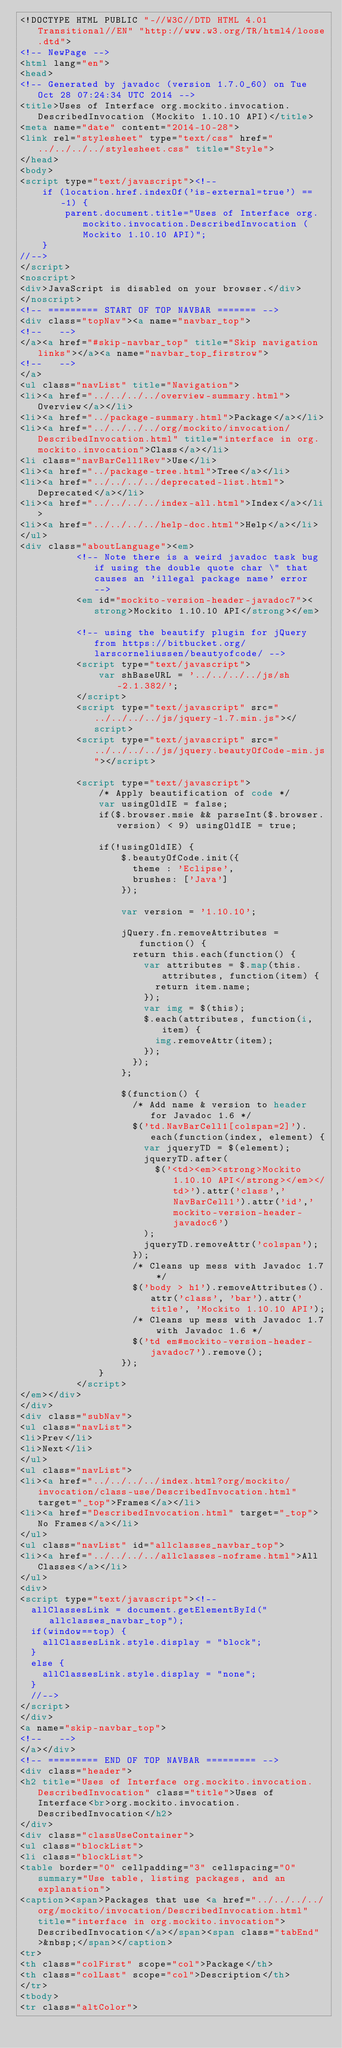<code> <loc_0><loc_0><loc_500><loc_500><_HTML_><!DOCTYPE HTML PUBLIC "-//W3C//DTD HTML 4.01 Transitional//EN" "http://www.w3.org/TR/html4/loose.dtd">
<!-- NewPage -->
<html lang="en">
<head>
<!-- Generated by javadoc (version 1.7.0_60) on Tue Oct 28 07:24:34 UTC 2014 -->
<title>Uses of Interface org.mockito.invocation.DescribedInvocation (Mockito 1.10.10 API)</title>
<meta name="date" content="2014-10-28">
<link rel="stylesheet" type="text/css" href="../../../../stylesheet.css" title="Style">
</head>
<body>
<script type="text/javascript"><!--
    if (location.href.indexOf('is-external=true') == -1) {
        parent.document.title="Uses of Interface org.mockito.invocation.DescribedInvocation (Mockito 1.10.10 API)";
    }
//-->
</script>
<noscript>
<div>JavaScript is disabled on your browser.</div>
</noscript>
<!-- ========= START OF TOP NAVBAR ======= -->
<div class="topNav"><a name="navbar_top">
<!--   -->
</a><a href="#skip-navbar_top" title="Skip navigation links"></a><a name="navbar_top_firstrow">
<!--   -->
</a>
<ul class="navList" title="Navigation">
<li><a href="../../../../overview-summary.html">Overview</a></li>
<li><a href="../package-summary.html">Package</a></li>
<li><a href="../../../../org/mockito/invocation/DescribedInvocation.html" title="interface in org.mockito.invocation">Class</a></li>
<li class="navBarCell1Rev">Use</li>
<li><a href="../package-tree.html">Tree</a></li>
<li><a href="../../../../deprecated-list.html">Deprecated</a></li>
<li><a href="../../../../index-all.html">Index</a></li>
<li><a href="../../../../help-doc.html">Help</a></li>
</ul>
<div class="aboutLanguage"><em>
          <!-- Note there is a weird javadoc task bug if using the double quote char \" that causes an 'illegal package name' error -->
          <em id="mockito-version-header-javadoc7"><strong>Mockito 1.10.10 API</strong></em>

          <!-- using the beautify plugin for jQuery from https://bitbucket.org/larscorneliussen/beautyofcode/ -->
          <script type="text/javascript">
              var shBaseURL = '../../../../js/sh-2.1.382/';
          </script>
          <script type="text/javascript" src="../../../../js/jquery-1.7.min.js"></script>
          <script type="text/javascript" src="../../../../js/jquery.beautyOfCode-min.js"></script>

          <script type="text/javascript">
              /* Apply beautification of code */
              var usingOldIE = false;
              if($.browser.msie && parseInt($.browser.version) < 9) usingOldIE = true;

              if(!usingOldIE) {
                  $.beautyOfCode.init({
                    theme : 'Eclipse',
                    brushes: ['Java']
                  });

                  var version = '1.10.10';

                  jQuery.fn.removeAttributes = function() {
                    return this.each(function() {
                      var attributes = $.map(this.attributes, function(item) {
                        return item.name;
                      });
                      var img = $(this);
                      $.each(attributes, function(i, item) {
                        img.removeAttr(item);
                      });
                    });
                  };

                  $(function() {
                    /* Add name & version to header for Javadoc 1.6 */
                    $('td.NavBarCell1[colspan=2]').each(function(index, element) {
                      var jqueryTD = $(element);
                      jqueryTD.after(
                        $('<td><em><strong>Mockito 1.10.10 API</strong></em></td>').attr('class','NavBarCell1').attr('id','mockito-version-header-javadoc6')
                      );
                      jqueryTD.removeAttr('colspan');
                    });
                    /* Cleans up mess with Javadoc 1.7 */
                    $('body > h1').removeAttributes().attr('class', 'bar').attr('title', 'Mockito 1.10.10 API');
                    /* Cleans up mess with Javadoc 1.7 with Javadoc 1.6 */
                    $('td em#mockito-version-header-javadoc7').remove();
                  });
              }
          </script>
</em></div>
</div>
<div class="subNav">
<ul class="navList">
<li>Prev</li>
<li>Next</li>
</ul>
<ul class="navList">
<li><a href="../../../../index.html?org/mockito/invocation/class-use/DescribedInvocation.html" target="_top">Frames</a></li>
<li><a href="DescribedInvocation.html" target="_top">No Frames</a></li>
</ul>
<ul class="navList" id="allclasses_navbar_top">
<li><a href="../../../../allclasses-noframe.html">All Classes</a></li>
</ul>
<div>
<script type="text/javascript"><!--
  allClassesLink = document.getElementById("allclasses_navbar_top");
  if(window==top) {
    allClassesLink.style.display = "block";
  }
  else {
    allClassesLink.style.display = "none";
  }
  //-->
</script>
</div>
<a name="skip-navbar_top">
<!--   -->
</a></div>
<!-- ========= END OF TOP NAVBAR ========= -->
<div class="header">
<h2 title="Uses of Interface org.mockito.invocation.DescribedInvocation" class="title">Uses of Interface<br>org.mockito.invocation.DescribedInvocation</h2>
</div>
<div class="classUseContainer">
<ul class="blockList">
<li class="blockList">
<table border="0" cellpadding="3" cellspacing="0" summary="Use table, listing packages, and an explanation">
<caption><span>Packages that use <a href="../../../../org/mockito/invocation/DescribedInvocation.html" title="interface in org.mockito.invocation">DescribedInvocation</a></span><span class="tabEnd">&nbsp;</span></caption>
<tr>
<th class="colFirst" scope="col">Package</th>
<th class="colLast" scope="col">Description</th>
</tr>
<tbody>
<tr class="altColor"></code> 